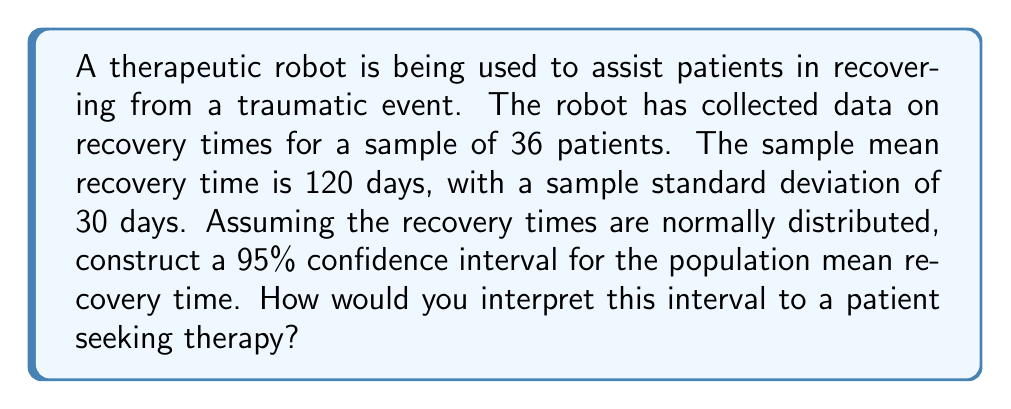Give your solution to this math problem. To construct a confidence interval for the population mean, we'll use the t-distribution since we don't know the population standard deviation. Here's the step-by-step process:

1. Identify the given information:
   - Sample size: $n = 36$
   - Sample mean: $\bar{x} = 120$ days
   - Sample standard deviation: $s = 30$ days
   - Confidence level: 95% (α = 0.05)

2. Find the critical t-value:
   - Degrees of freedom: $df = n - 1 = 36 - 1 = 35$
   - For a 95% confidence interval, we need $t_{0.025, 35}$
   - Using a t-table or calculator, we find $t_{0.025, 35} \approx 2.030$

3. Calculate the margin of error:
   $E = t_{0.025, 35} \cdot \frac{s}{\sqrt{n}} = 2.030 \cdot \frac{30}{\sqrt{36}} \approx 10.15$

4. Construct the confidence interval:
   $CI = \bar{x} \pm E = 120 \pm 10.15$

5. Therefore, the 95% confidence interval is approximately (109.85, 130.15) days.

Interpretation for a patient:
We can be 95% confident that the true average recovery time for all patients using this therapeutic robot falls between 109.85 and 130.15 days. This means that while individual recovery times may vary, we expect most patients to recover within this range. It's important to note that your personal recovery time may be shorter or longer than this average, as everyone's healing process is unique.
Answer: The 95% confidence interval for the population mean recovery time is approximately (109.85, 130.15) days. 